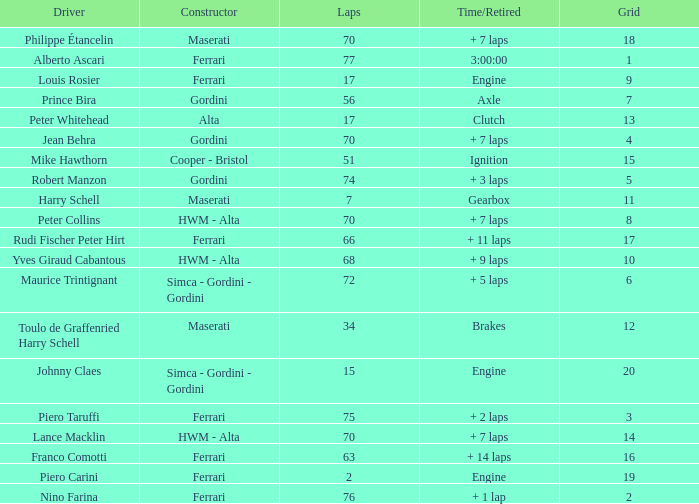How many grids for peter collins? 1.0. Would you mind parsing the complete table? {'header': ['Driver', 'Constructor', 'Laps', 'Time/Retired', 'Grid'], 'rows': [['Philippe Étancelin', 'Maserati', '70', '+ 7 laps', '18'], ['Alberto Ascari', 'Ferrari', '77', '3:00:00', '1'], ['Louis Rosier', 'Ferrari', '17', 'Engine', '9'], ['Prince Bira', 'Gordini', '56', 'Axle', '7'], ['Peter Whitehead', 'Alta', '17', 'Clutch', '13'], ['Jean Behra', 'Gordini', '70', '+ 7 laps', '4'], ['Mike Hawthorn', 'Cooper - Bristol', '51', 'Ignition', '15'], ['Robert Manzon', 'Gordini', '74', '+ 3 laps', '5'], ['Harry Schell', 'Maserati', '7', 'Gearbox', '11'], ['Peter Collins', 'HWM - Alta', '70', '+ 7 laps', '8'], ['Rudi Fischer Peter Hirt', 'Ferrari', '66', '+ 11 laps', '17'], ['Yves Giraud Cabantous', 'HWM - Alta', '68', '+ 9 laps', '10'], ['Maurice Trintignant', 'Simca - Gordini - Gordini', '72', '+ 5 laps', '6'], ['Toulo de Graffenried Harry Schell', 'Maserati', '34', 'Brakes', '12'], ['Johnny Claes', 'Simca - Gordini - Gordini', '15', 'Engine', '20'], ['Piero Taruffi', 'Ferrari', '75', '+ 2 laps', '3'], ['Lance Macklin', 'HWM - Alta', '70', '+ 7 laps', '14'], ['Franco Comotti', 'Ferrari', '63', '+ 14 laps', '16'], ['Piero Carini', 'Ferrari', '2', 'Engine', '19'], ['Nino Farina', 'Ferrari', '76', '+ 1 lap', '2']]} 